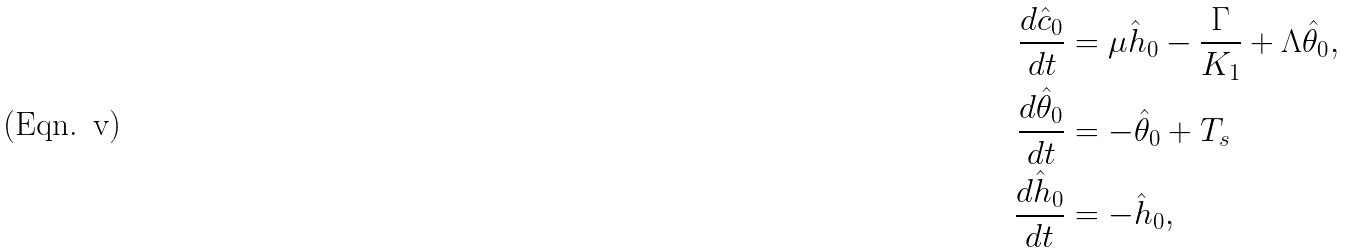<formula> <loc_0><loc_0><loc_500><loc_500>\frac { d \hat { c } _ { 0 } } { d t } & = \mu \hat { h } _ { 0 } - \frac { \Gamma } { K _ { 1 } } + \Lambda \hat { \theta } _ { 0 } , \\ \frac { d \hat { \theta } _ { 0 } } { d t } & = - \hat { \theta } _ { 0 } + T _ { s } \\ \frac { d \hat { h } _ { 0 } } { d t } & = - \hat { h } _ { 0 } ,</formula> 